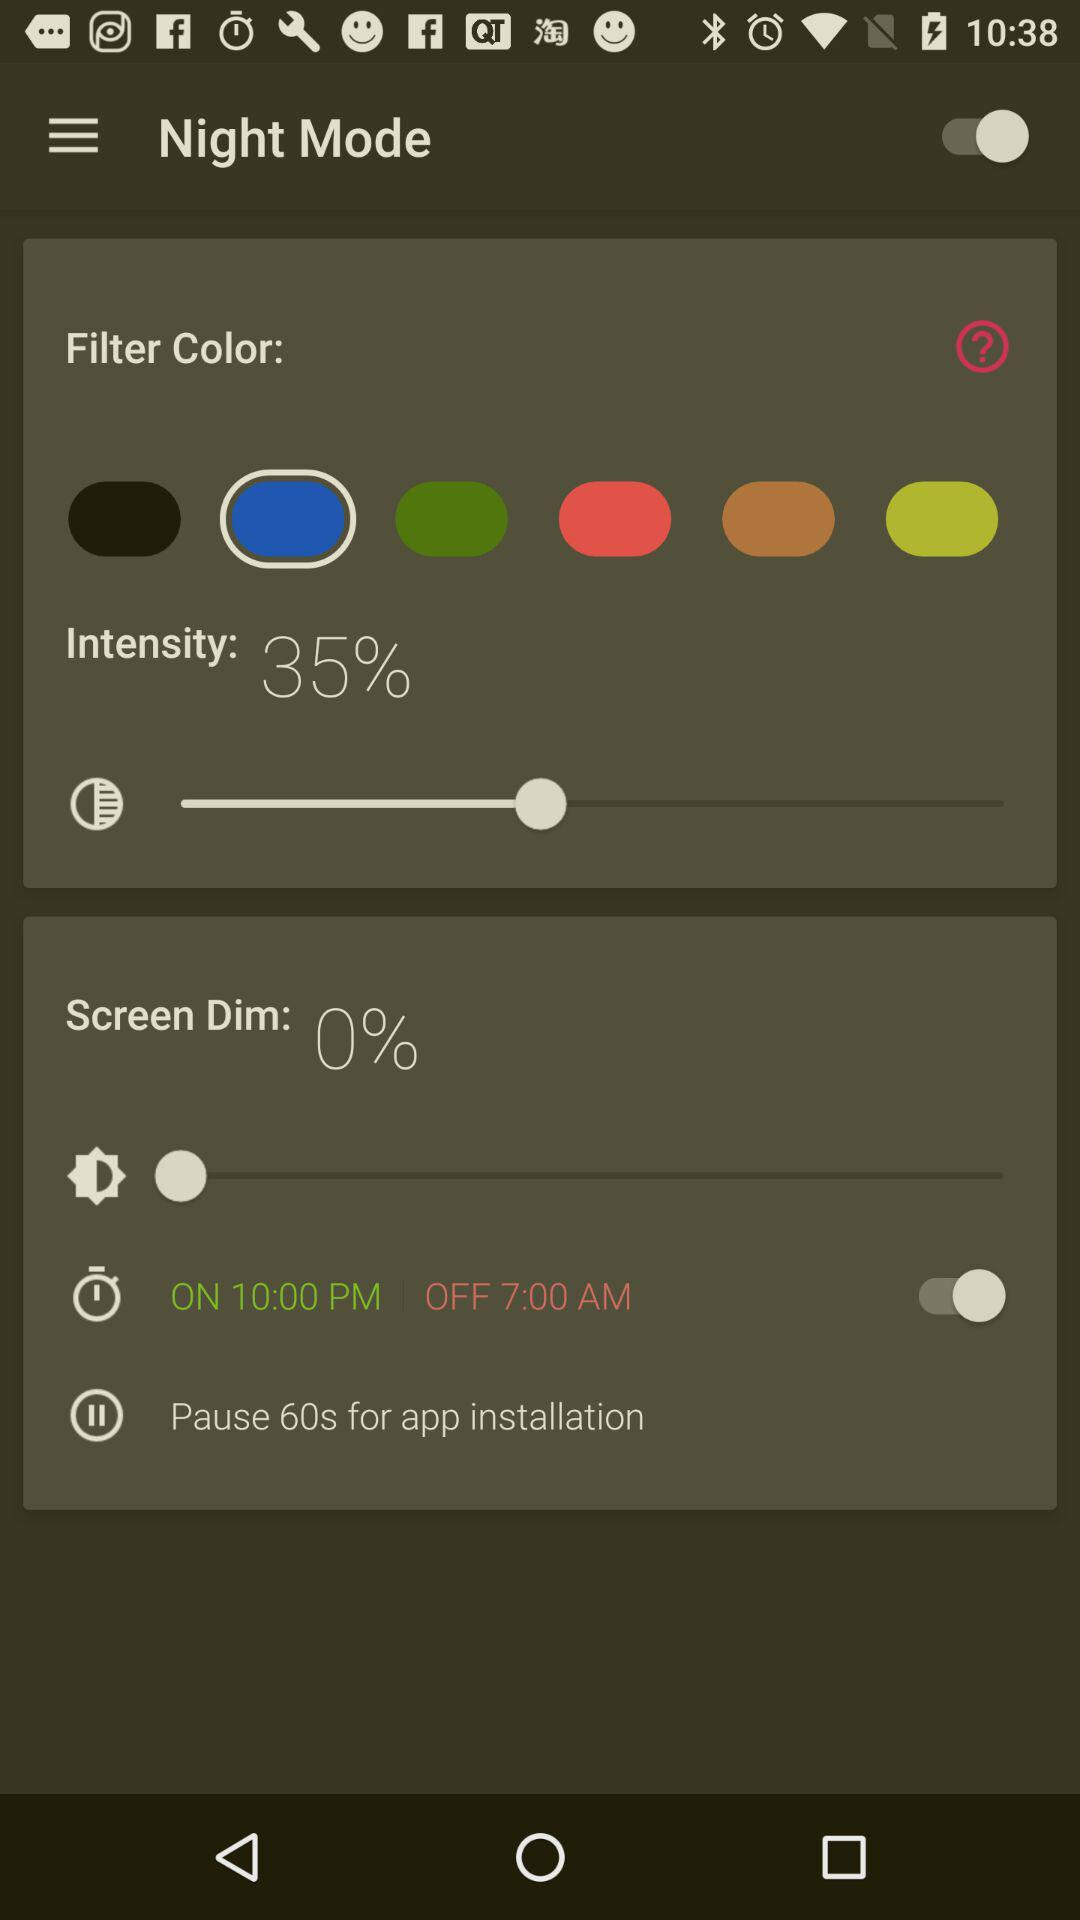What is the status of "Night Mode"? The status of "Night Mode" is "on". 